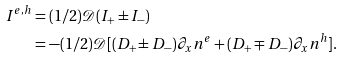Convert formula to latex. <formula><loc_0><loc_0><loc_500><loc_500>I ^ { e , h } & = ( 1 / 2 ) \mathcal { D } ( I _ { + } \pm I _ { - } ) \\ & = - ( 1 / 2 ) \mathcal { D } [ ( D _ { + } \pm D _ { - } ) \partial _ { x } n ^ { e } + ( D _ { + } \mp D _ { - } ) \partial _ { x } n ^ { h } ] .</formula> 